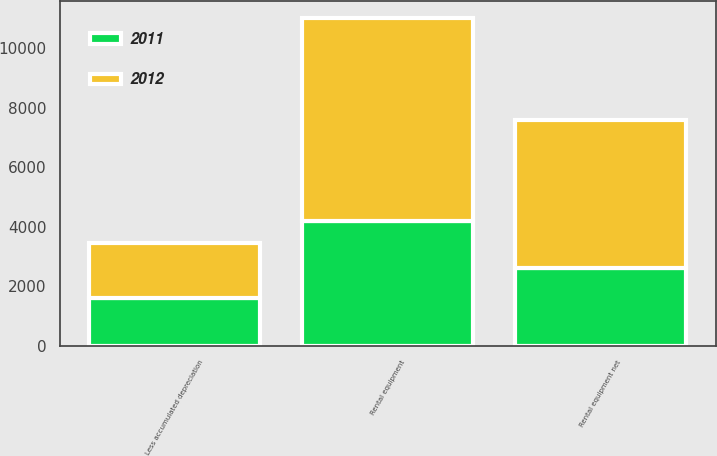<chart> <loc_0><loc_0><loc_500><loc_500><stacked_bar_chart><ecel><fcel>Rental equipment<fcel>Less accumulated depreciation<fcel>Rental equipment net<nl><fcel>2012<fcel>6820<fcel>1854<fcel>4966<nl><fcel>2011<fcel>4209<fcel>1592<fcel>2617<nl></chart> 